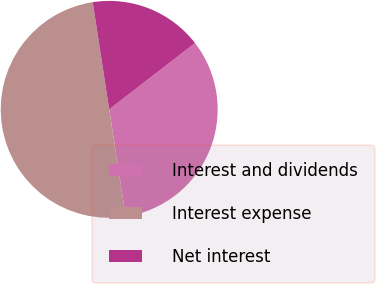Convert chart. <chart><loc_0><loc_0><loc_500><loc_500><pie_chart><fcel>Interest and dividends<fcel>Interest expense<fcel>Net interest<nl><fcel>33.04%<fcel>50.0%<fcel>16.96%<nl></chart> 